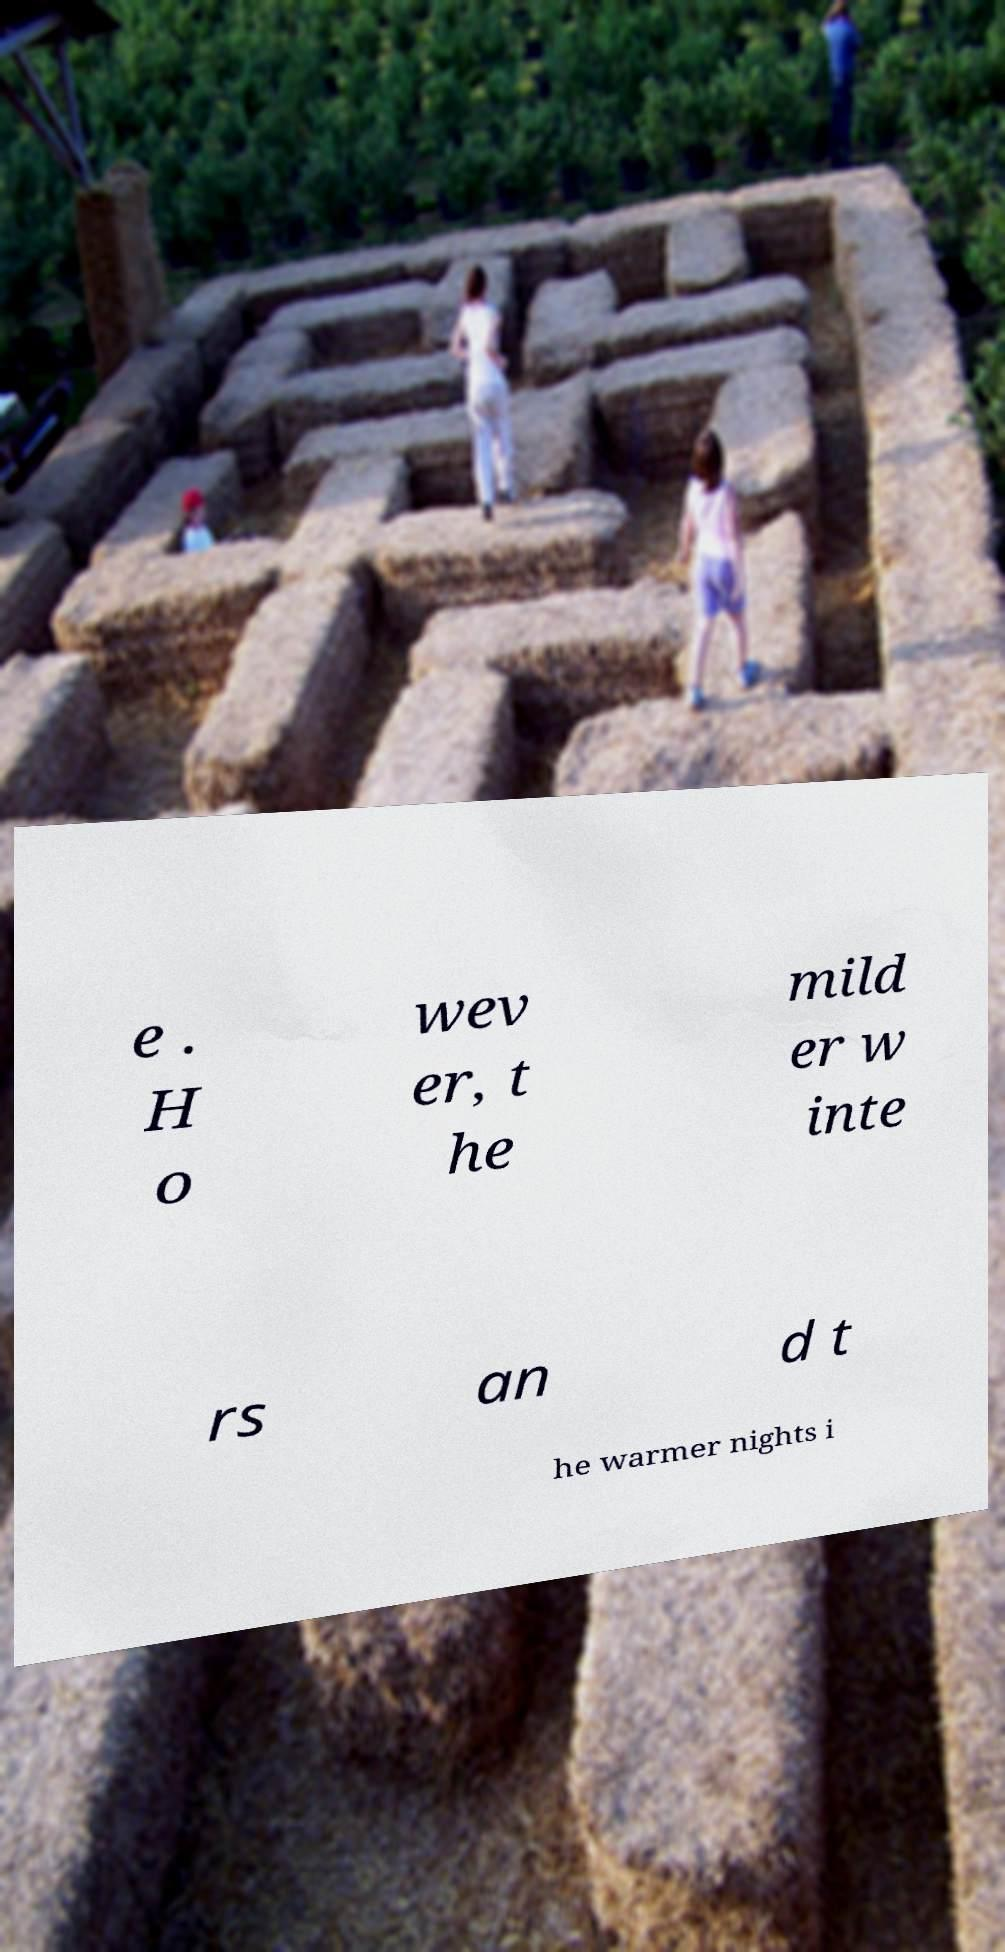There's text embedded in this image that I need extracted. Can you transcribe it verbatim? e . H o wev er, t he mild er w inte rs an d t he warmer nights i 